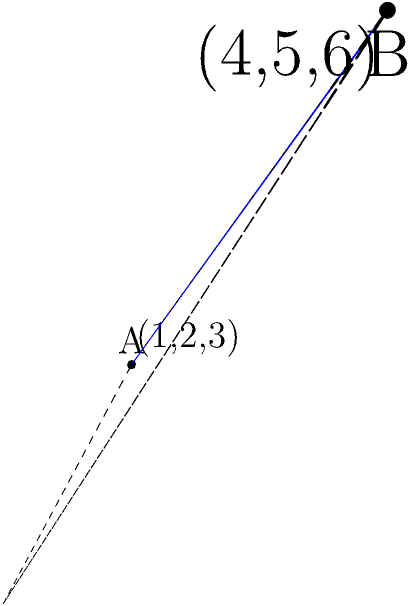In a 3D coordinate system, two points represent the locations of potential Ruby developers: A(1,2,3) and B(4,5,6). Calculate the distance between these two points to determine which candidate is closer to the company's office. How would you explain this calculation to a non-technical hiring manager? To calculate the distance between two points in 3D space, we use the following steps:

1. Identify the coordinates of both points:
   Point A: $(x_1, y_1, z_1) = (1, 2, 3)$
   Point B: $(x_2, y_2, z_2) = (4, 5, 6)$

2. Use the 3D distance formula:
   $$d = \sqrt{(x_2-x_1)^2 + (y_2-y_1)^2 + (z_2-z_1)^2}$$

3. Substitute the values:
   $$d = \sqrt{(4-1)^2 + (5-2)^2 + (6-3)^2}$$

4. Simplify:
   $$d = \sqrt{3^2 + 3^2 + 3^2} = \sqrt{9 + 9 + 9} = \sqrt{27}$$

5. Calculate the final result:
   $$d = \sqrt{27} = 3\sqrt{3} \approx 5.196$$

Explanation for a non-technical hiring manager:
"Imagine each coordinate as a direction: x is east-west, y is north-south, and z is up-down. We're measuring how far apart the two points are 'as the crow flies' in this 3D space. We calculate the difference in each direction, square these differences, add them up, and then take the square root. This gives us the straight-line distance between the two points, just like measuring with a ruler, but in three dimensions."
Answer: $3\sqrt{3}$ units or approximately 5.196 units 